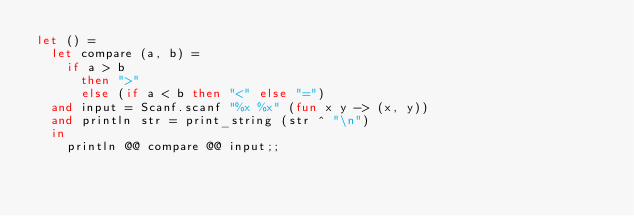Convert code to text. <code><loc_0><loc_0><loc_500><loc_500><_OCaml_>let () =
  let compare (a, b) =
    if a > b
      then ">"
      else (if a < b then "<" else "=")
  and input = Scanf.scanf "%x %x" (fun x y -> (x, y))
  and println str = print_string (str ^ "\n")
  in
    println @@ compare @@ input;;
</code> 